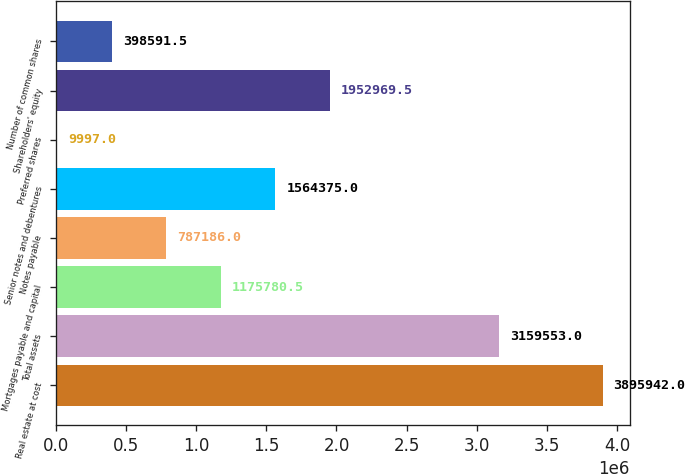Convert chart. <chart><loc_0><loc_0><loc_500><loc_500><bar_chart><fcel>Real estate at cost<fcel>Total assets<fcel>Mortgages payable and capital<fcel>Notes payable<fcel>Senior notes and debentures<fcel>Preferred shares<fcel>Shareholders' equity<fcel>Number of common shares<nl><fcel>3.89594e+06<fcel>3.15955e+06<fcel>1.17578e+06<fcel>787186<fcel>1.56438e+06<fcel>9997<fcel>1.95297e+06<fcel>398592<nl></chart> 